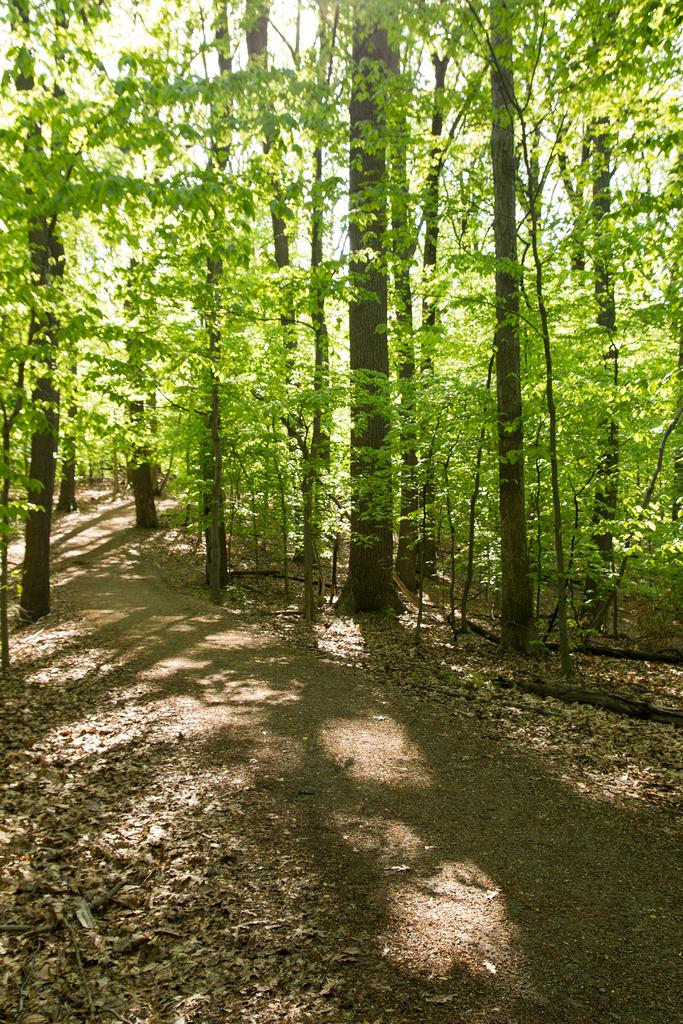What type of vegetation can be seen in the image? There are trees in the image. What part of the trees is visible at the bottom of the image? There are leaves at the bottom of the image. What time of day is it in the image, and is there a river visible? The time of day is not mentioned in the image, and there is no river visible. 